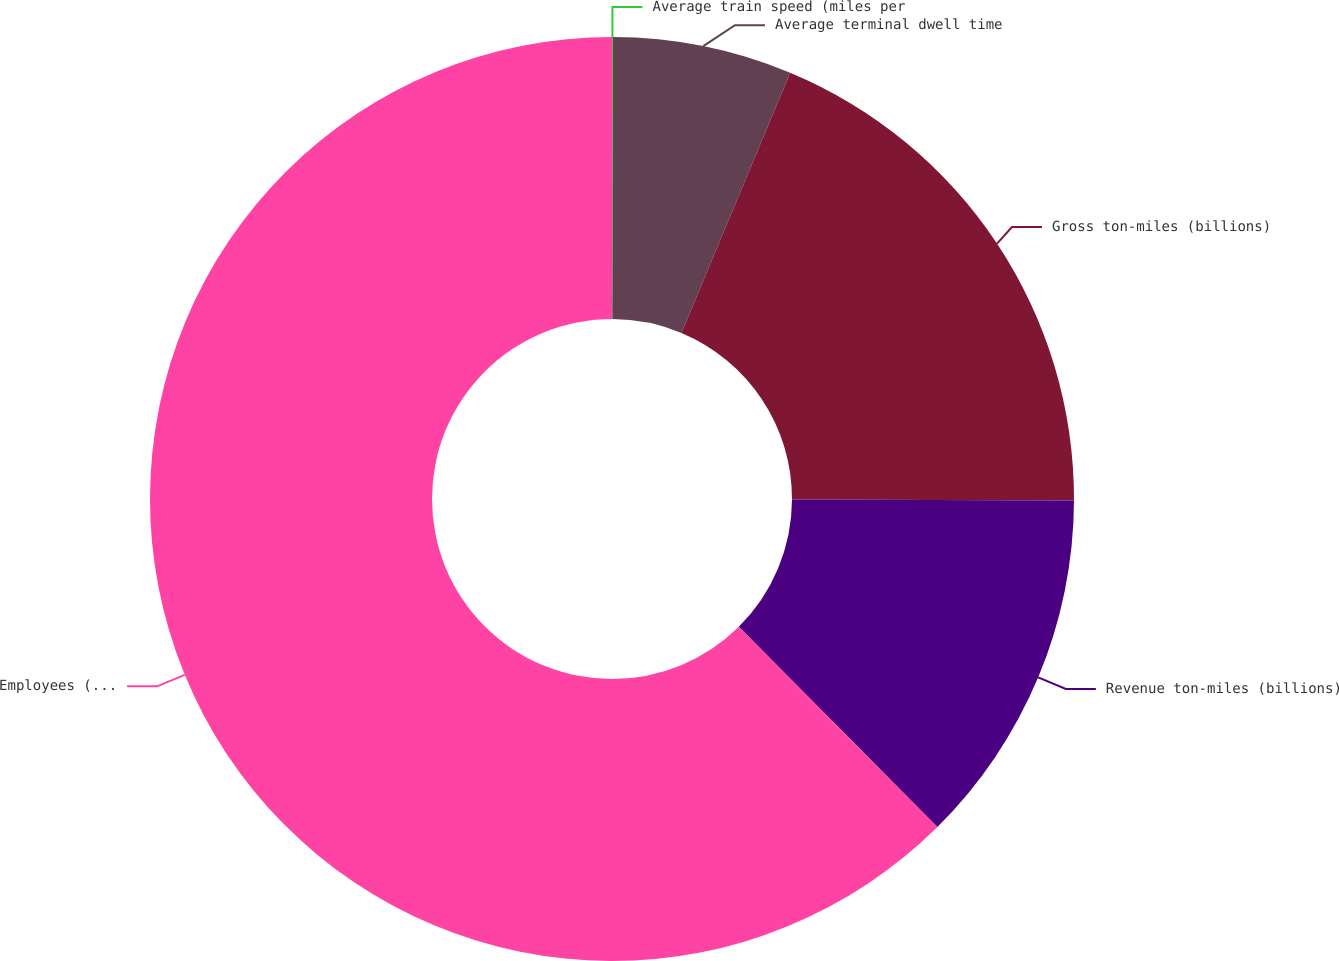<chart> <loc_0><loc_0><loc_500><loc_500><pie_chart><fcel>Average train speed (miles per<fcel>Average terminal dwell time<fcel>Gross ton-miles (billions)<fcel>Revenue ton-miles (billions)<fcel>Employees (average)<nl><fcel>0.03%<fcel>6.27%<fcel>18.75%<fcel>12.51%<fcel>62.43%<nl></chart> 